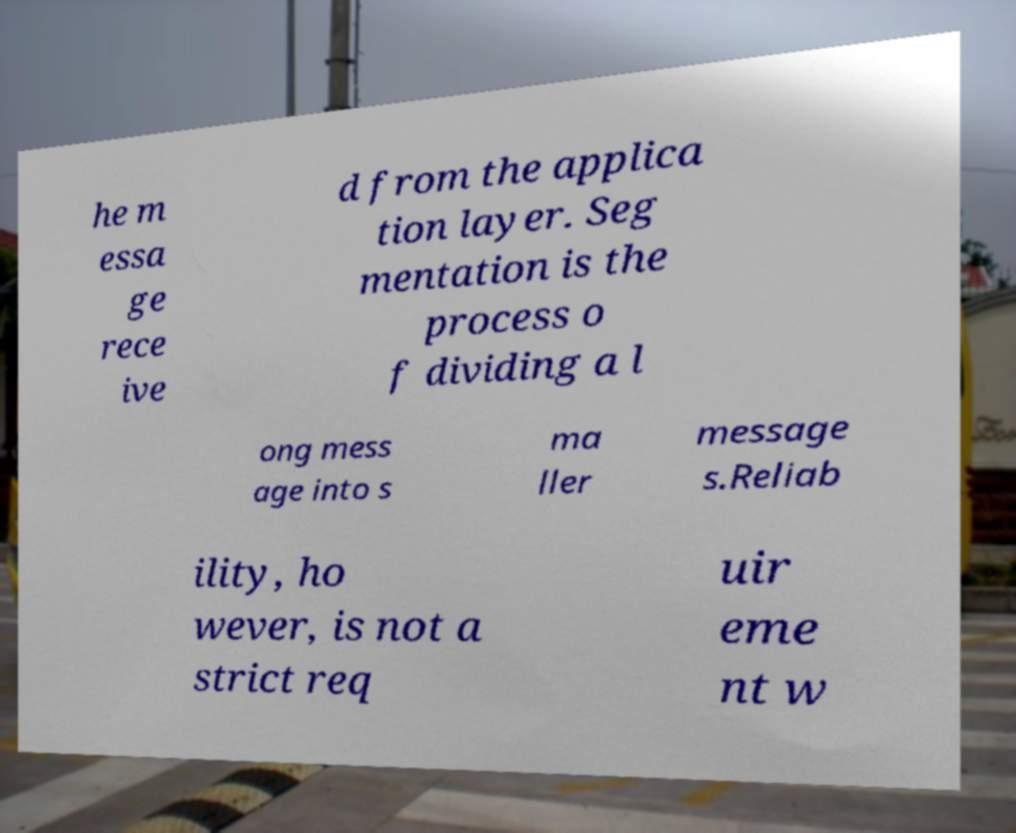What messages or text are displayed in this image? I need them in a readable, typed format. he m essa ge rece ive d from the applica tion layer. Seg mentation is the process o f dividing a l ong mess age into s ma ller message s.Reliab ility, ho wever, is not a strict req uir eme nt w 